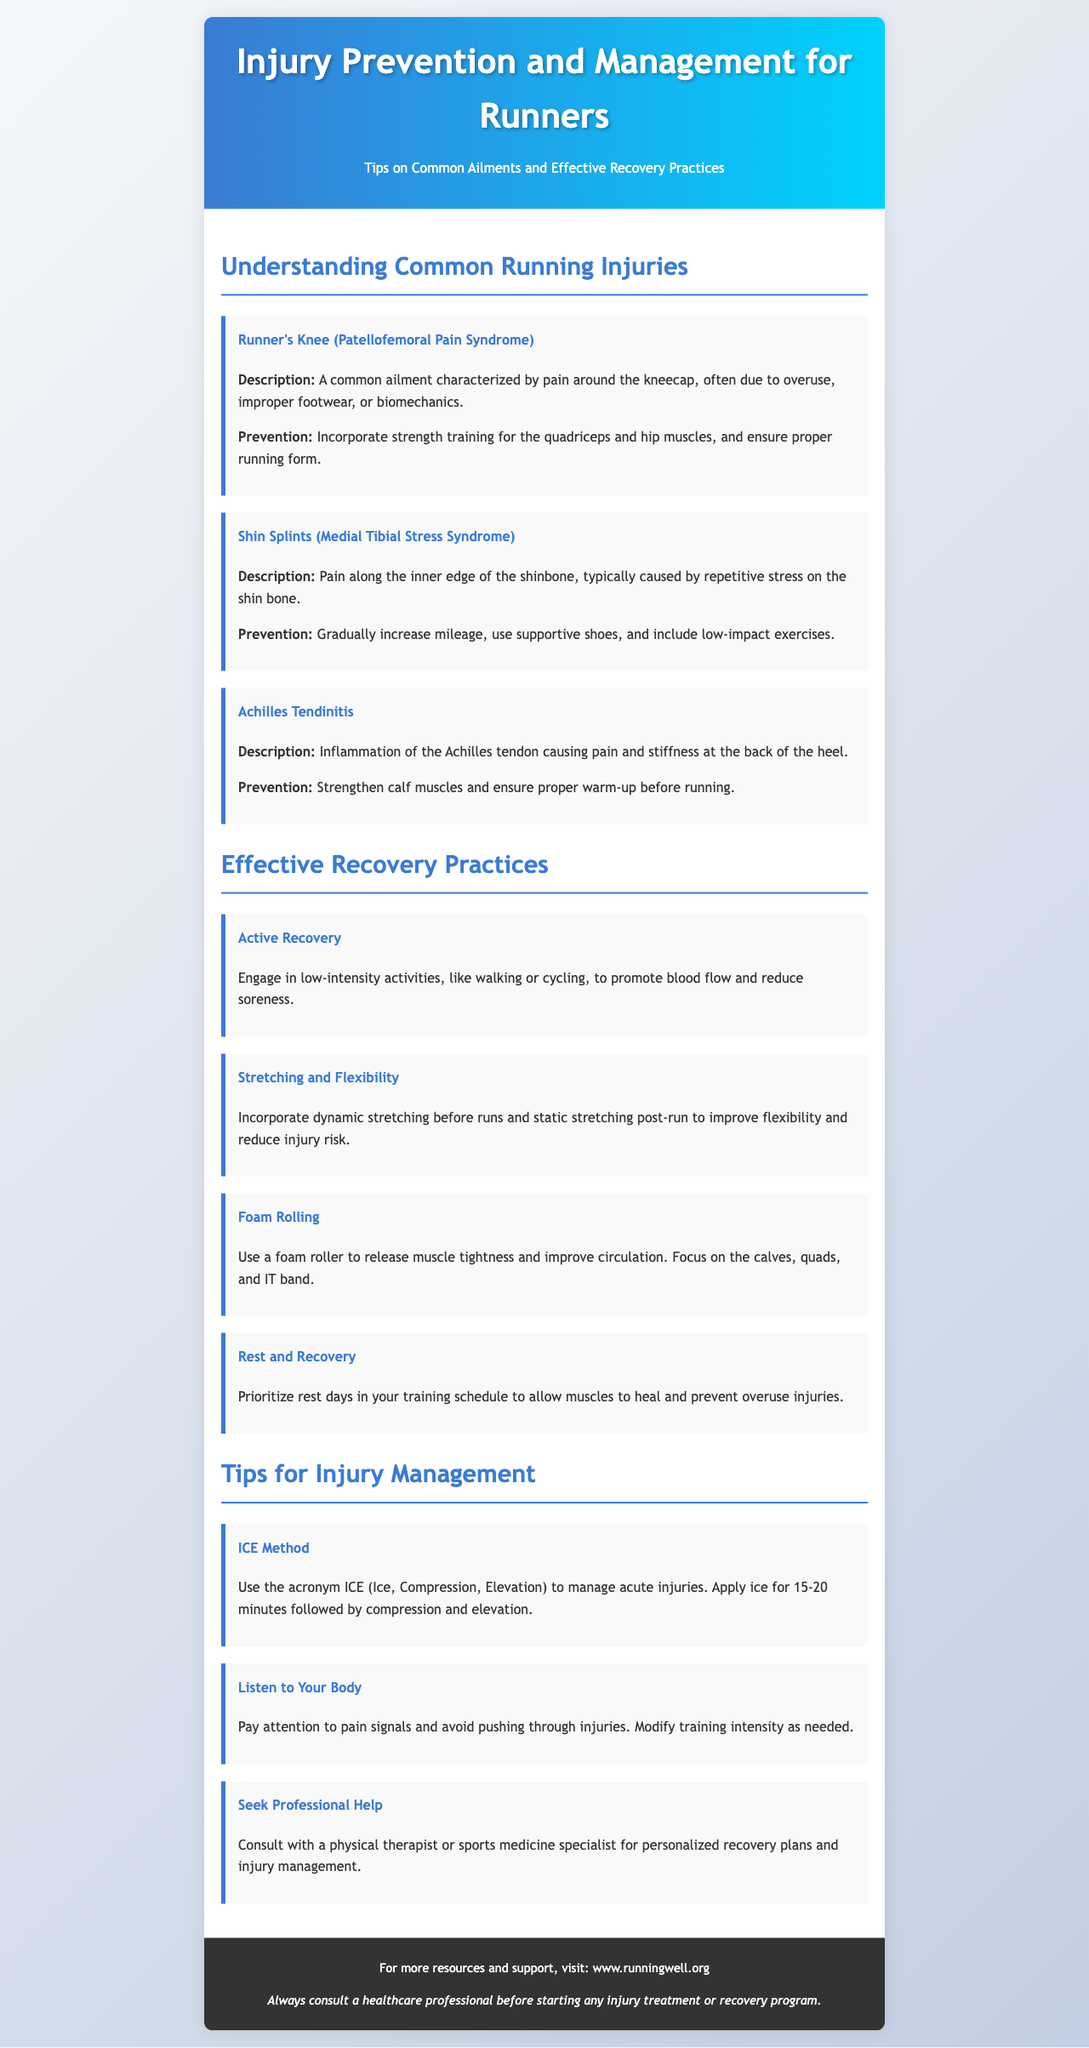What is the title of the brochure? The title is prominently displayed at the top of the document, indicating the main theme.
Answer: Injury Prevention and Management for Runners What is one common ailment associated with running? The document lists multiple common ailments under the "Understanding Common Running Injuries" section.
Answer: Runner's Knee What is a prevention tip for shin splints? The prevention tips are outlined for each injury, specifically addressing how to avoid them.
Answer: Gradually increase mileage What is the recommended duration for applying ice in the ICE method? The document specifies the time needed for icing to manage injuries effectively.
Answer: 15-20 minutes What is one effective recovery practice mentioned? Recovery practices are suggested to help runners recover from training and injuries.
Answer: Active Recovery Which body part is focused on for foam rolling? The document mentions specific areas to target when using a foam roller for muscle tightness.
Answer: Calves What should you do if you experience pain while running? The document offers tips on how to handle discomfort and injury signals during training.
Answer: Listen to Your Body Where can you find more resources and support for running? The footer provides additional information on accessing more resources related to running.
Answer: www.runningwell.org What is the color scheme used in the brochure's header? The design choices are evident from the description of the header background.
Answer: A gradient from blue to cyan 